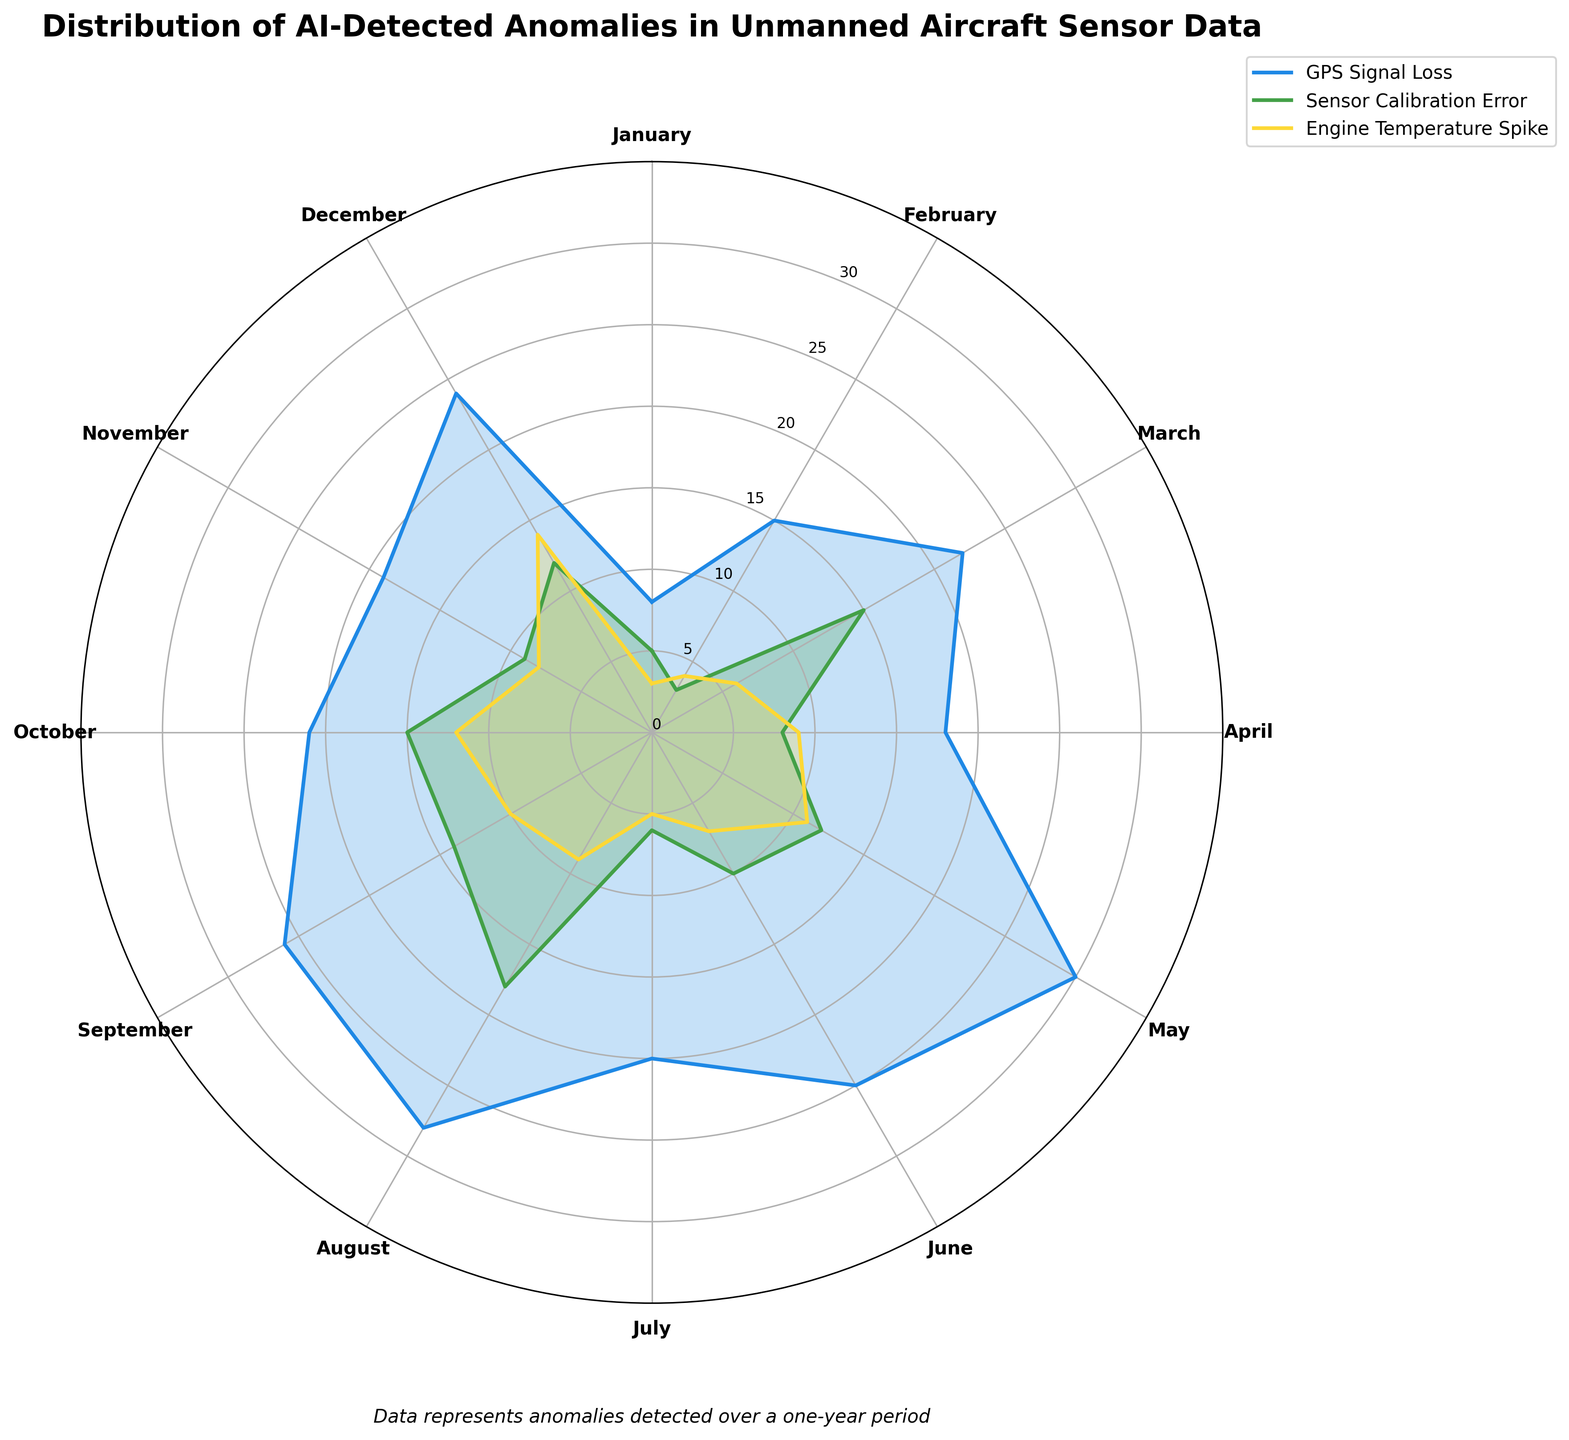What is the title of the figure? The title is usually located at the top of the figure. In this case, the title "Distribution of AI-Detected Anomalies in Unmanned Aircraft Sensor Data" can be found there.
Answer: Distribution of AI-Detected Anomalies in Unmanned Aircraft Sensor Data Which anomaly type has the highest number of detections in March? First, identify the month of March in the figure. Then look for the anomaly type with the longest line or largest area in the segment for March.
Answer: GPS Signal Loss What is the maximum number of detections for Engine Temperature Spike across all months? For each month, observe the radial length or area dedicated to "Engine Temperature Spike" and find the maximum value. This would be the outermost point corresponding to this anomaly.
Answer: 14 During which month were Sensor Calibration Errors detected the least? Look at each segment corresponding to "Sensor Calibration Error" across all months and identify the month with the smallest section length or area.
Answer: February How does the number of GPS Signal Loss detections in January compare to December? Compare the radial lengths or areas for "GPS Signal Loss" in the segments for January and December. The one with the longer radial length or larger area has more detections.
Answer: December has more Across which months do all three types of anomalies have values greater than 10 at least once? For each anomaly type, check the radial lengths for all months and determine which months have at least one section exceeding the value 10.
Answer: May, August, October, December What is the color assigned to Engine Temperature Spike anomalies? Identify the segment corresponding to "Engine Temperature Spike" in the plot and read the color used to fill this segment.
Answer: Yellow Which month shows the highest overall anomaly detections when combining all three types? For each month, sum the detections for all three anomaly types and determine which month has the highest total sum.
Answer: May How many types of anomalies were detected in April? Check the radial lengths or areas for each anomaly type in April. Count the types with non-zero values.
Answer: 3 What is the average number of GPS Signal Loss detections from January to June? Add up the number of detections for "GPS Signal Loss" from January to June and divide by 6 (the total number of months in this period).
Answer: 19.67 